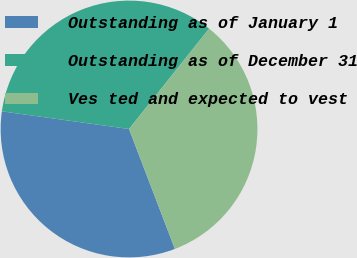Convert chart to OTSL. <chart><loc_0><loc_0><loc_500><loc_500><pie_chart><fcel>Outstanding as of January 1<fcel>Outstanding as of December 31<fcel>Ves ted and expected to vest<nl><fcel>33.01%<fcel>33.52%<fcel>33.47%<nl></chart> 